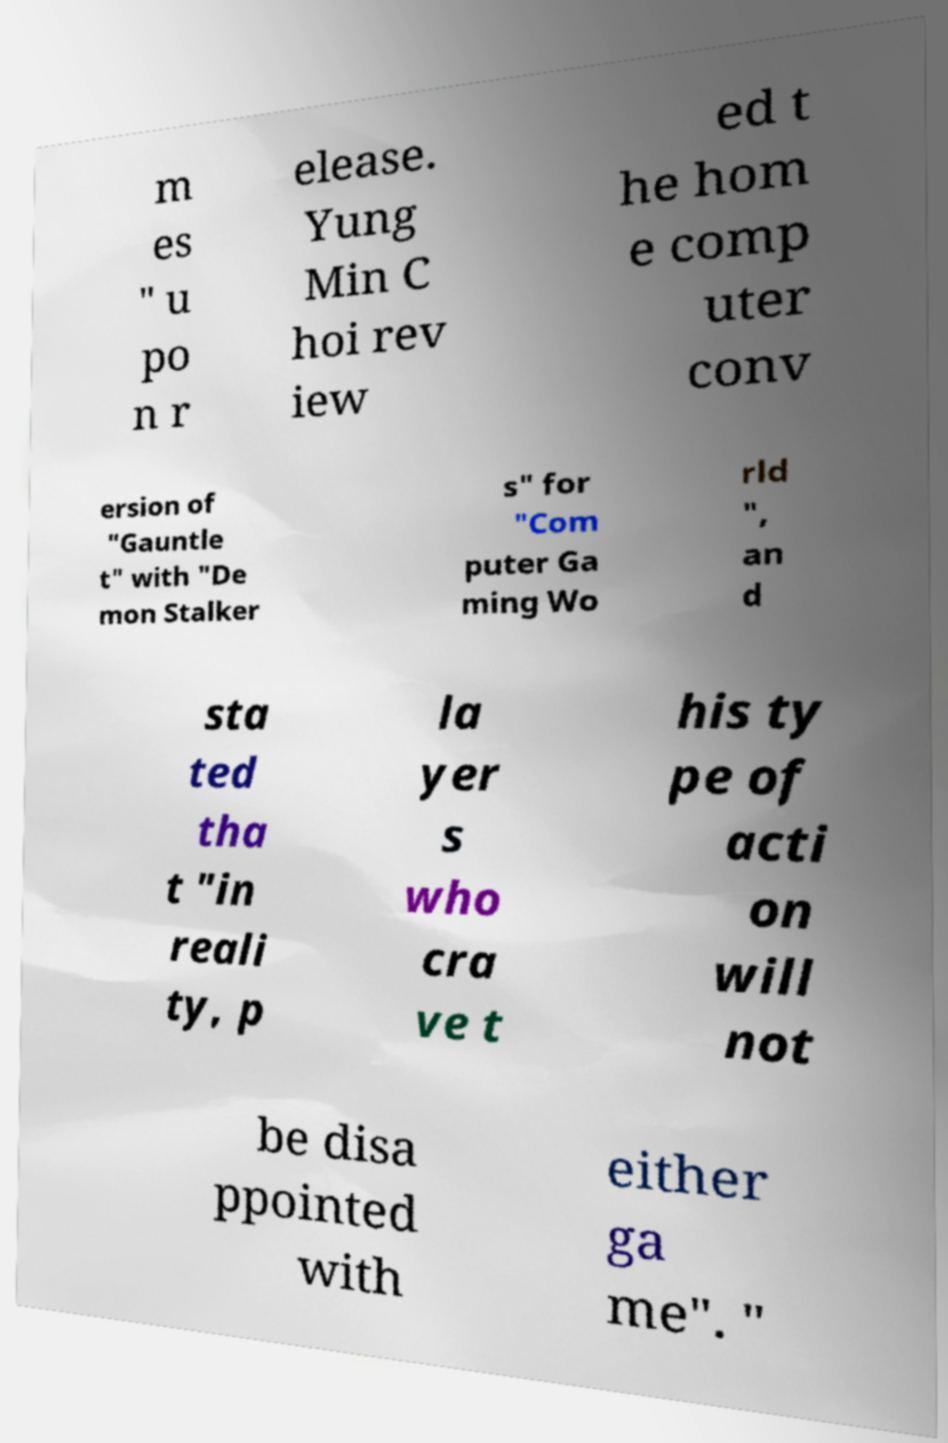Please read and relay the text visible in this image. What does it say? m es " u po n r elease. Yung Min C hoi rev iew ed t he hom e comp uter conv ersion of "Gauntle t" with "De mon Stalker s" for "Com puter Ga ming Wo rld ", an d sta ted tha t "in reali ty, p la yer s who cra ve t his ty pe of acti on will not be disa ppointed with either ga me". " 